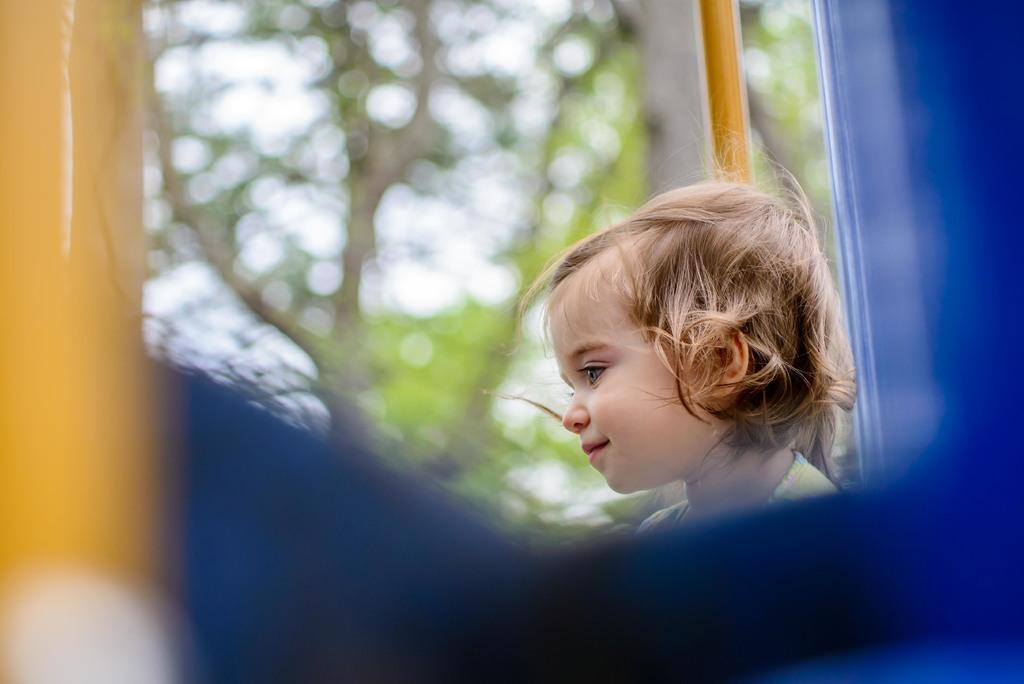What is the main subject of the image? There is a baby in the image. What is the baby wearing? The baby is wearing a white dress. Can you describe the object in the image that is yellow and blue in color? The object is yellow and blue in color, but it is blurry. What can be seen in the background of the image? There is a tree and the sky visible in the background of the image. Can you tell me how many bananas are hanging from the tree in the image? There are no bananas visible in the image; only a tree and the sky are present in the background. What type of owl can be seen perched on the baby's head in the image? There is no owl present in the image; the baby is wearing a white dress and there is a blurry yellow and blue object in the image. 